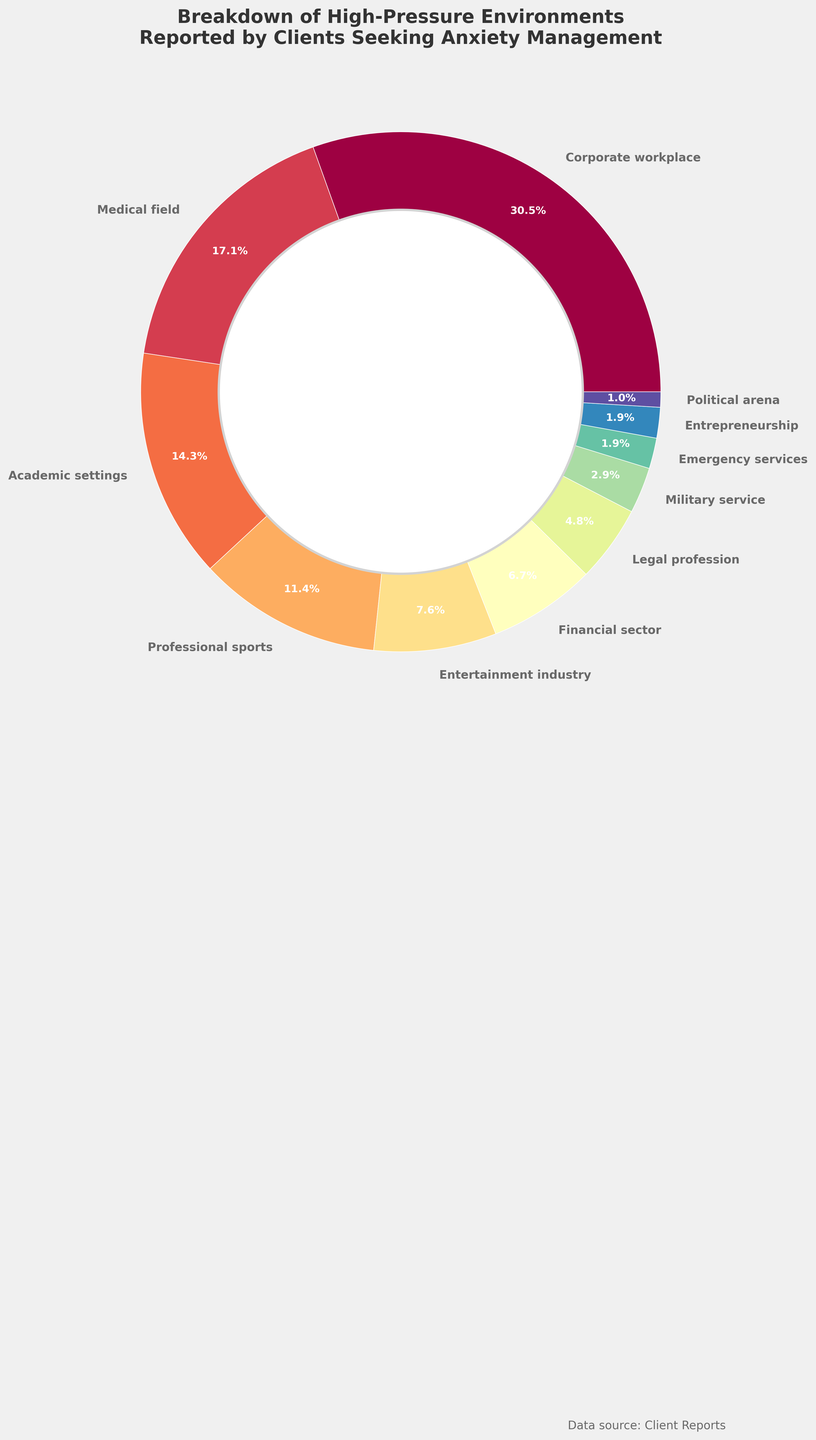Which environment has the highest percentage? The largest wedge in the pie chart belongs to the "Corporate workplace". By checking the percentage label on this wedge, it indicates "32%".
Answer: Corporate workplace How do the percentages of the Medical field and the Academic settings combined compare to the Corporate workplace? First, find the percentages for the Medical field and Academic settings which are 18% and 15% respectively. Add these: 18% + 15% = 33%. Then, compare this sum to the Corporate workplace, which is 32%. So, 33% > 32%.
Answer: 33% > 32% What is the percentage difference between the Professional sports and the Legal profession environments? The percentage for Professional sports is 12%, and for Legal profession, it is 5%. The difference in percentage is calculated as 12% - 5% = 7%.
Answer: 7% Which environments constitute less than 5%? By examining the wedges and their labels, we see that Military service (3%), Emergency services (2%), Entrepreneurship (2%), and Political arena (1%) all are less than 5%.
Answer: Military service, Emergency services, Entrepreneurship, Political arena How does the sum of percentages of the Entertainment industry and Financial sector compare to the Medical field? The percentages for the Entertainment industry and Financial sector are 8% and 7% respectively, totaling 8% + 7% = 15%. The percentage for the Medical field is 18%. Comparing these sums, we get 15% < 18%.
Answer: 15% < 18% What is the average percentage of the top three environments? The top three environments by percentage are Corporate workplace (32%), Medical field (18%), and Academic settings (15%). The average is calculated as (32% + 18% + 15%) / 3 = 65% / 3 ≈ 21.67%.
Answer: 21.67% Which sector represents the smallest proportion of high-pressure environments? The smallest wedge in the pie chart represents the "Political arena" which has a percentage label of "1%".
Answer: Political arena What percentage do the Corporate workplace and Professional sports environments together account for? By adding the percentages for Corporate workplace (32%) and Professional sports (12%), the sum is 32% + 12% = 44%.
Answer: 44% Which two environments have percentages totaling to the closest value to 20%? A close pair is Financial sector (7%) and Entertainment industry (8%), but they total to 15%. The next closest pair is Professional sports (12%) and Legal profession (5%), which total to 17%. The pair Medical field (18%) and Political arena (1%) total to 19%. Therefore, Medical field and Political arena sum to the closest value to 20%.
Answer: Medical field and Political arena 